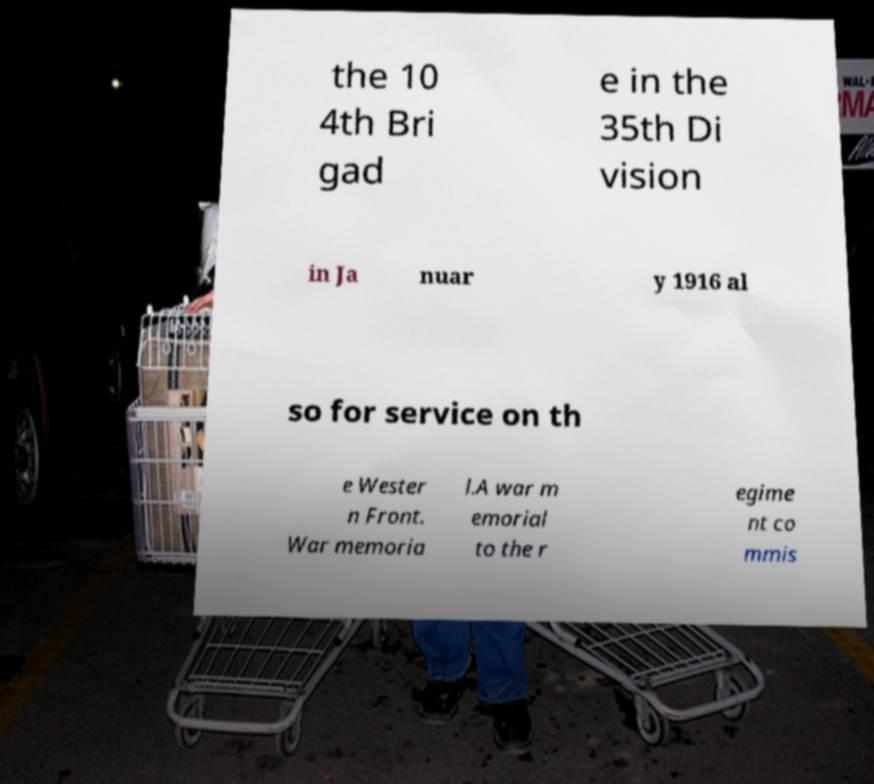Could you extract and type out the text from this image? the 10 4th Bri gad e in the 35th Di vision in Ja nuar y 1916 al so for service on th e Wester n Front. War memoria l.A war m emorial to the r egime nt co mmis 